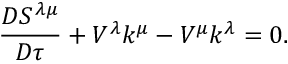<formula> <loc_0><loc_0><loc_500><loc_500>{ \frac { D S ^ { \lambda \mu } } { D \tau } } + V ^ { \lambda } k ^ { \mu } - V ^ { \mu } k ^ { \lambda } = 0 .</formula> 